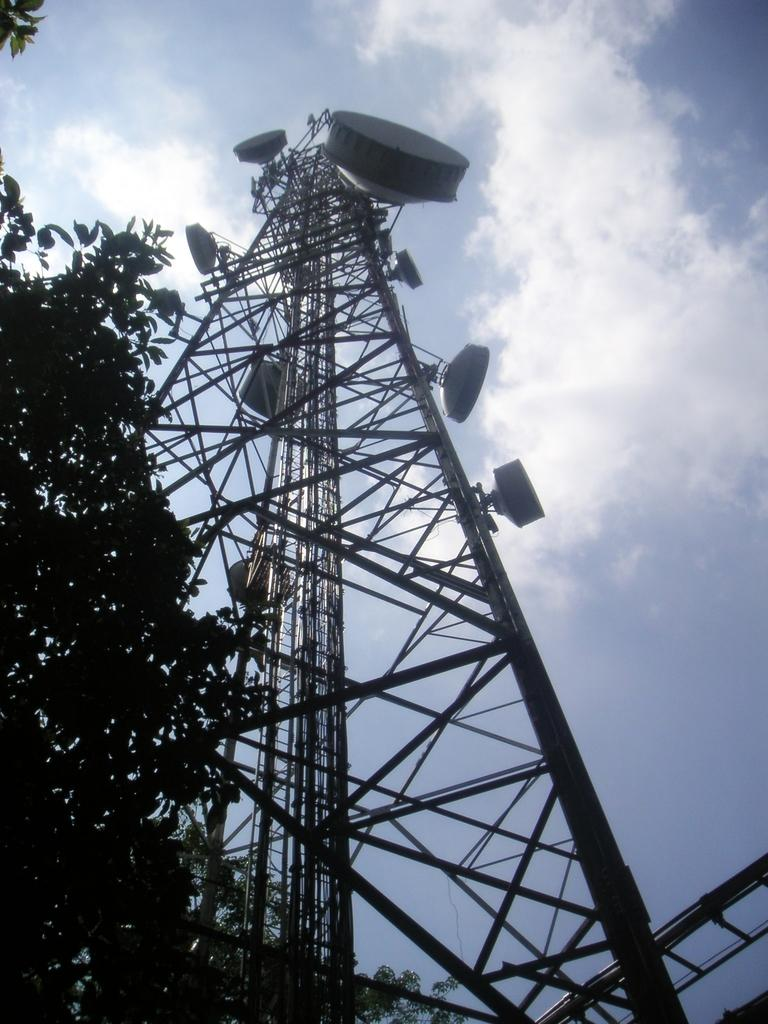What type of vegetation is on the right side of the image? There is a tree on the right side of the image. What structure can be seen in the image? There is a tower in the image. How would you describe the sky in the image? The sky is blue and cloudy in the image. How many beds are visible in the image? There are no beds present in the image. What type of body is shown interacting with the tower in the image? There is no body shown interacting with the tower in the image; only the tower and the tree are present. 